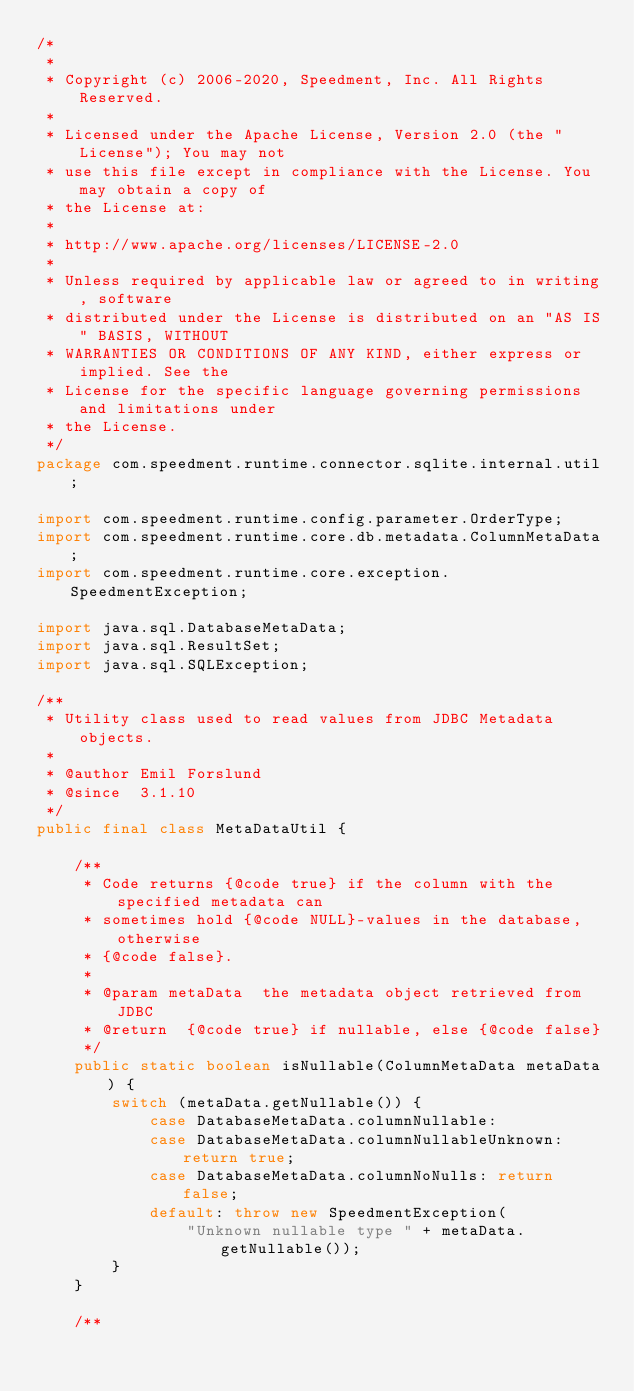Convert code to text. <code><loc_0><loc_0><loc_500><loc_500><_Java_>/*
 *
 * Copyright (c) 2006-2020, Speedment, Inc. All Rights Reserved.
 *
 * Licensed under the Apache License, Version 2.0 (the "License"); You may not
 * use this file except in compliance with the License. You may obtain a copy of
 * the License at:
 *
 * http://www.apache.org/licenses/LICENSE-2.0
 *
 * Unless required by applicable law or agreed to in writing, software
 * distributed under the License is distributed on an "AS IS" BASIS, WITHOUT
 * WARRANTIES OR CONDITIONS OF ANY KIND, either express or implied. See the
 * License for the specific language governing permissions and limitations under
 * the License.
 */
package com.speedment.runtime.connector.sqlite.internal.util;

import com.speedment.runtime.config.parameter.OrderType;
import com.speedment.runtime.core.db.metadata.ColumnMetaData;
import com.speedment.runtime.core.exception.SpeedmentException;

import java.sql.DatabaseMetaData;
import java.sql.ResultSet;
import java.sql.SQLException;

/**
 * Utility class used to read values from JDBC Metadata objects.
 *
 * @author Emil Forslund
 * @since  3.1.10
 */
public final class MetaDataUtil {

    /**
     * Code returns {@code true} if the column with the specified metadata can
     * sometimes hold {@code NULL}-values in the database, otherwise
     * {@code false}.
     *
     * @param metaData  the metadata object retrieved from JDBC
     * @return  {@code true} if nullable, else {@code false}
     */
    public static boolean isNullable(ColumnMetaData metaData) {
        switch (metaData.getNullable()) {
            case DatabaseMetaData.columnNullable:
            case DatabaseMetaData.columnNullableUnknown: return true;
            case DatabaseMetaData.columnNoNulls: return false;
            default: throw new SpeedmentException(
                "Unknown nullable type " + metaData.getNullable());
        }
    }

    /**</code> 